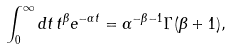<formula> <loc_0><loc_0><loc_500><loc_500>\int _ { 0 } ^ { \infty } d t \, t ^ { \beta } e ^ { - \alpha t } = \alpha ^ { - \beta - 1 } \Gamma ( \beta + 1 ) ,</formula> 